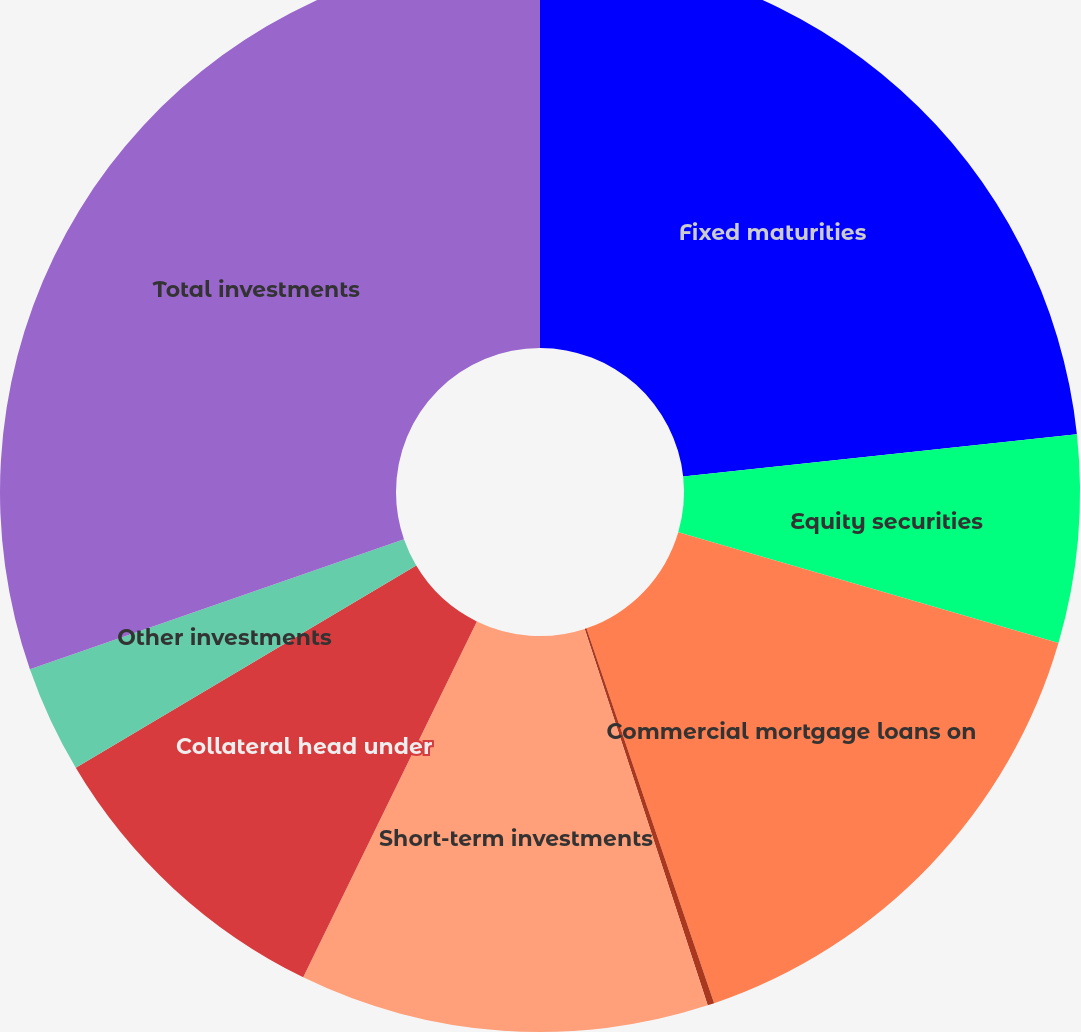Convert chart to OTSL. <chart><loc_0><loc_0><loc_500><loc_500><pie_chart><fcel>Fixed maturities<fcel>Equity securities<fcel>Commercial mortgage loans on<fcel>Policy loans<fcel>Short-term investments<fcel>Collateral head under<fcel>Other investments<fcel>Total investments<nl><fcel>23.29%<fcel>6.22%<fcel>15.26%<fcel>0.2%<fcel>12.25%<fcel>9.24%<fcel>3.21%<fcel>30.32%<nl></chart> 